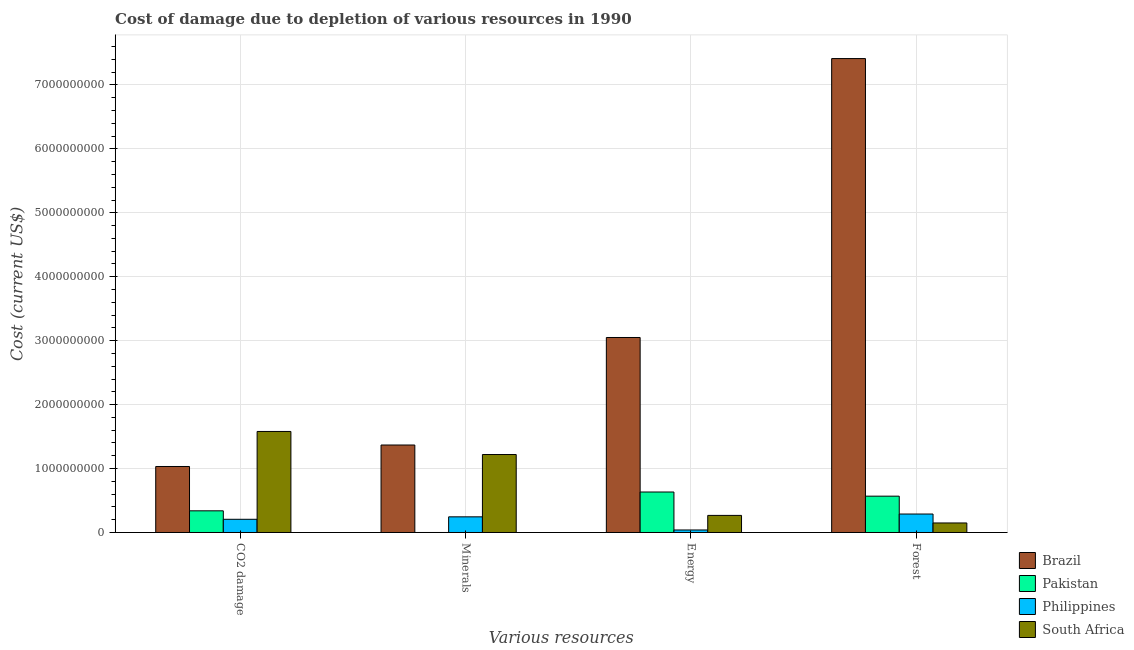How many different coloured bars are there?
Offer a very short reply. 4. Are the number of bars per tick equal to the number of legend labels?
Provide a short and direct response. Yes. Are the number of bars on each tick of the X-axis equal?
Offer a terse response. Yes. What is the label of the 3rd group of bars from the left?
Your answer should be very brief. Energy. What is the cost of damage due to depletion of forests in Pakistan?
Keep it short and to the point. 5.68e+08. Across all countries, what is the maximum cost of damage due to depletion of energy?
Your answer should be compact. 3.05e+09. Across all countries, what is the minimum cost of damage due to depletion of forests?
Your response must be concise. 1.49e+08. In which country was the cost of damage due to depletion of forests maximum?
Offer a terse response. Brazil. What is the total cost of damage due to depletion of coal in the graph?
Your answer should be compact. 3.16e+09. What is the difference between the cost of damage due to depletion of coal in South Africa and that in Brazil?
Make the answer very short. 5.48e+08. What is the difference between the cost of damage due to depletion of minerals in Brazil and the cost of damage due to depletion of coal in South Africa?
Keep it short and to the point. -2.12e+08. What is the average cost of damage due to depletion of coal per country?
Your answer should be very brief. 7.89e+08. What is the difference between the cost of damage due to depletion of coal and cost of damage due to depletion of energy in Brazil?
Your answer should be very brief. -2.02e+09. What is the ratio of the cost of damage due to depletion of minerals in South Africa to that in Pakistan?
Give a very brief answer. 3.53e+04. Is the cost of damage due to depletion of forests in Pakistan less than that in Philippines?
Give a very brief answer. No. Is the difference between the cost of damage due to depletion of forests in Pakistan and Philippines greater than the difference between the cost of damage due to depletion of coal in Pakistan and Philippines?
Provide a succinct answer. Yes. What is the difference between the highest and the second highest cost of damage due to depletion of minerals?
Provide a short and direct response. 1.49e+08. What is the difference between the highest and the lowest cost of damage due to depletion of energy?
Provide a short and direct response. 3.01e+09. In how many countries, is the cost of damage due to depletion of minerals greater than the average cost of damage due to depletion of minerals taken over all countries?
Offer a terse response. 2. Is the sum of the cost of damage due to depletion of forests in Pakistan and South Africa greater than the maximum cost of damage due to depletion of energy across all countries?
Your response must be concise. No. What does the 2nd bar from the left in Minerals represents?
Your answer should be very brief. Pakistan. What does the 4th bar from the right in Minerals represents?
Provide a short and direct response. Brazil. How many bars are there?
Your response must be concise. 16. Does the graph contain any zero values?
Make the answer very short. No. Where does the legend appear in the graph?
Keep it short and to the point. Bottom right. What is the title of the graph?
Your answer should be very brief. Cost of damage due to depletion of various resources in 1990 . Does "Burundi" appear as one of the legend labels in the graph?
Provide a short and direct response. No. What is the label or title of the X-axis?
Give a very brief answer. Various resources. What is the label or title of the Y-axis?
Offer a very short reply. Cost (current US$). What is the Cost (current US$) of Brazil in CO2 damage?
Offer a very short reply. 1.03e+09. What is the Cost (current US$) of Pakistan in CO2 damage?
Your response must be concise. 3.39e+08. What is the Cost (current US$) in Philippines in CO2 damage?
Your answer should be very brief. 2.06e+08. What is the Cost (current US$) of South Africa in CO2 damage?
Make the answer very short. 1.58e+09. What is the Cost (current US$) in Brazil in Minerals?
Make the answer very short. 1.37e+09. What is the Cost (current US$) in Pakistan in Minerals?
Provide a succinct answer. 3.45e+04. What is the Cost (current US$) of Philippines in Minerals?
Ensure brevity in your answer.  2.45e+08. What is the Cost (current US$) of South Africa in Minerals?
Provide a succinct answer. 1.22e+09. What is the Cost (current US$) of Brazil in Energy?
Offer a terse response. 3.05e+09. What is the Cost (current US$) in Pakistan in Energy?
Provide a succinct answer. 6.33e+08. What is the Cost (current US$) in Philippines in Energy?
Your response must be concise. 3.93e+07. What is the Cost (current US$) of South Africa in Energy?
Provide a succinct answer. 2.67e+08. What is the Cost (current US$) in Brazil in Forest?
Provide a short and direct response. 7.41e+09. What is the Cost (current US$) in Pakistan in Forest?
Ensure brevity in your answer.  5.68e+08. What is the Cost (current US$) of Philippines in Forest?
Your answer should be compact. 2.89e+08. What is the Cost (current US$) in South Africa in Forest?
Your answer should be very brief. 1.49e+08. Across all Various resources, what is the maximum Cost (current US$) in Brazil?
Offer a very short reply. 7.41e+09. Across all Various resources, what is the maximum Cost (current US$) of Pakistan?
Your response must be concise. 6.33e+08. Across all Various resources, what is the maximum Cost (current US$) in Philippines?
Provide a short and direct response. 2.89e+08. Across all Various resources, what is the maximum Cost (current US$) of South Africa?
Provide a short and direct response. 1.58e+09. Across all Various resources, what is the minimum Cost (current US$) of Brazil?
Provide a short and direct response. 1.03e+09. Across all Various resources, what is the minimum Cost (current US$) of Pakistan?
Keep it short and to the point. 3.45e+04. Across all Various resources, what is the minimum Cost (current US$) in Philippines?
Offer a terse response. 3.93e+07. Across all Various resources, what is the minimum Cost (current US$) of South Africa?
Keep it short and to the point. 1.49e+08. What is the total Cost (current US$) in Brazil in the graph?
Keep it short and to the point. 1.29e+1. What is the total Cost (current US$) in Pakistan in the graph?
Ensure brevity in your answer.  1.54e+09. What is the total Cost (current US$) in Philippines in the graph?
Offer a terse response. 7.79e+08. What is the total Cost (current US$) in South Africa in the graph?
Offer a very short reply. 3.22e+09. What is the difference between the Cost (current US$) in Brazil in CO2 damage and that in Minerals?
Ensure brevity in your answer.  -3.36e+08. What is the difference between the Cost (current US$) of Pakistan in CO2 damage and that in Minerals?
Provide a short and direct response. 3.39e+08. What is the difference between the Cost (current US$) in Philippines in CO2 damage and that in Minerals?
Your response must be concise. -3.85e+07. What is the difference between the Cost (current US$) of South Africa in CO2 damage and that in Minerals?
Your response must be concise. 3.61e+08. What is the difference between the Cost (current US$) in Brazil in CO2 damage and that in Energy?
Offer a terse response. -2.02e+09. What is the difference between the Cost (current US$) in Pakistan in CO2 damage and that in Energy?
Your answer should be compact. -2.94e+08. What is the difference between the Cost (current US$) in Philippines in CO2 damage and that in Energy?
Give a very brief answer. 1.67e+08. What is the difference between the Cost (current US$) of South Africa in CO2 damage and that in Energy?
Keep it short and to the point. 1.31e+09. What is the difference between the Cost (current US$) in Brazil in CO2 damage and that in Forest?
Ensure brevity in your answer.  -6.38e+09. What is the difference between the Cost (current US$) of Pakistan in CO2 damage and that in Forest?
Offer a terse response. -2.29e+08. What is the difference between the Cost (current US$) in Philippines in CO2 damage and that in Forest?
Provide a succinct answer. -8.23e+07. What is the difference between the Cost (current US$) of South Africa in CO2 damage and that in Forest?
Your answer should be compact. 1.43e+09. What is the difference between the Cost (current US$) of Brazil in Minerals and that in Energy?
Offer a very short reply. -1.68e+09. What is the difference between the Cost (current US$) in Pakistan in Minerals and that in Energy?
Make the answer very short. -6.33e+08. What is the difference between the Cost (current US$) in Philippines in Minerals and that in Energy?
Offer a terse response. 2.06e+08. What is the difference between the Cost (current US$) in South Africa in Minerals and that in Energy?
Provide a short and direct response. 9.52e+08. What is the difference between the Cost (current US$) in Brazil in Minerals and that in Forest?
Your answer should be compact. -6.04e+09. What is the difference between the Cost (current US$) in Pakistan in Minerals and that in Forest?
Keep it short and to the point. -5.68e+08. What is the difference between the Cost (current US$) of Philippines in Minerals and that in Forest?
Provide a short and direct response. -4.39e+07. What is the difference between the Cost (current US$) of South Africa in Minerals and that in Forest?
Provide a succinct answer. 1.07e+09. What is the difference between the Cost (current US$) of Brazil in Energy and that in Forest?
Give a very brief answer. -4.36e+09. What is the difference between the Cost (current US$) of Pakistan in Energy and that in Forest?
Your answer should be compact. 6.49e+07. What is the difference between the Cost (current US$) of Philippines in Energy and that in Forest?
Provide a succinct answer. -2.49e+08. What is the difference between the Cost (current US$) of South Africa in Energy and that in Forest?
Provide a succinct answer. 1.18e+08. What is the difference between the Cost (current US$) of Brazil in CO2 damage and the Cost (current US$) of Pakistan in Minerals?
Your response must be concise. 1.03e+09. What is the difference between the Cost (current US$) of Brazil in CO2 damage and the Cost (current US$) of Philippines in Minerals?
Ensure brevity in your answer.  7.87e+08. What is the difference between the Cost (current US$) in Brazil in CO2 damage and the Cost (current US$) in South Africa in Minerals?
Provide a short and direct response. -1.87e+08. What is the difference between the Cost (current US$) in Pakistan in CO2 damage and the Cost (current US$) in Philippines in Minerals?
Offer a very short reply. 9.40e+07. What is the difference between the Cost (current US$) of Pakistan in CO2 damage and the Cost (current US$) of South Africa in Minerals?
Keep it short and to the point. -8.81e+08. What is the difference between the Cost (current US$) of Philippines in CO2 damage and the Cost (current US$) of South Africa in Minerals?
Your answer should be compact. -1.01e+09. What is the difference between the Cost (current US$) in Brazil in CO2 damage and the Cost (current US$) in Pakistan in Energy?
Provide a succinct answer. 3.99e+08. What is the difference between the Cost (current US$) of Brazil in CO2 damage and the Cost (current US$) of Philippines in Energy?
Your response must be concise. 9.93e+08. What is the difference between the Cost (current US$) in Brazil in CO2 damage and the Cost (current US$) in South Africa in Energy?
Ensure brevity in your answer.  7.65e+08. What is the difference between the Cost (current US$) of Pakistan in CO2 damage and the Cost (current US$) of Philippines in Energy?
Keep it short and to the point. 2.99e+08. What is the difference between the Cost (current US$) in Pakistan in CO2 damage and the Cost (current US$) in South Africa in Energy?
Ensure brevity in your answer.  7.14e+07. What is the difference between the Cost (current US$) of Philippines in CO2 damage and the Cost (current US$) of South Africa in Energy?
Provide a short and direct response. -6.10e+07. What is the difference between the Cost (current US$) of Brazil in CO2 damage and the Cost (current US$) of Pakistan in Forest?
Offer a very short reply. 4.64e+08. What is the difference between the Cost (current US$) of Brazil in CO2 damage and the Cost (current US$) of Philippines in Forest?
Offer a very short reply. 7.43e+08. What is the difference between the Cost (current US$) of Brazil in CO2 damage and the Cost (current US$) of South Africa in Forest?
Provide a succinct answer. 8.83e+08. What is the difference between the Cost (current US$) of Pakistan in CO2 damage and the Cost (current US$) of Philippines in Forest?
Provide a succinct answer. 5.01e+07. What is the difference between the Cost (current US$) of Pakistan in CO2 damage and the Cost (current US$) of South Africa in Forest?
Your response must be concise. 1.90e+08. What is the difference between the Cost (current US$) of Philippines in CO2 damage and the Cost (current US$) of South Africa in Forest?
Your response must be concise. 5.74e+07. What is the difference between the Cost (current US$) in Brazil in Minerals and the Cost (current US$) in Pakistan in Energy?
Your answer should be very brief. 7.35e+08. What is the difference between the Cost (current US$) in Brazil in Minerals and the Cost (current US$) in Philippines in Energy?
Offer a terse response. 1.33e+09. What is the difference between the Cost (current US$) in Brazil in Minerals and the Cost (current US$) in South Africa in Energy?
Your response must be concise. 1.10e+09. What is the difference between the Cost (current US$) in Pakistan in Minerals and the Cost (current US$) in Philippines in Energy?
Keep it short and to the point. -3.93e+07. What is the difference between the Cost (current US$) in Pakistan in Minerals and the Cost (current US$) in South Africa in Energy?
Ensure brevity in your answer.  -2.67e+08. What is the difference between the Cost (current US$) of Philippines in Minerals and the Cost (current US$) of South Africa in Energy?
Make the answer very short. -2.25e+07. What is the difference between the Cost (current US$) in Brazil in Minerals and the Cost (current US$) in Pakistan in Forest?
Your answer should be very brief. 8.00e+08. What is the difference between the Cost (current US$) in Brazil in Minerals and the Cost (current US$) in Philippines in Forest?
Offer a very short reply. 1.08e+09. What is the difference between the Cost (current US$) of Brazil in Minerals and the Cost (current US$) of South Africa in Forest?
Ensure brevity in your answer.  1.22e+09. What is the difference between the Cost (current US$) in Pakistan in Minerals and the Cost (current US$) in Philippines in Forest?
Keep it short and to the point. -2.89e+08. What is the difference between the Cost (current US$) in Pakistan in Minerals and the Cost (current US$) in South Africa in Forest?
Your answer should be very brief. -1.49e+08. What is the difference between the Cost (current US$) in Philippines in Minerals and the Cost (current US$) in South Africa in Forest?
Provide a succinct answer. 9.58e+07. What is the difference between the Cost (current US$) of Brazil in Energy and the Cost (current US$) of Pakistan in Forest?
Keep it short and to the point. 2.48e+09. What is the difference between the Cost (current US$) of Brazil in Energy and the Cost (current US$) of Philippines in Forest?
Provide a short and direct response. 2.76e+09. What is the difference between the Cost (current US$) of Brazil in Energy and the Cost (current US$) of South Africa in Forest?
Offer a terse response. 2.90e+09. What is the difference between the Cost (current US$) of Pakistan in Energy and the Cost (current US$) of Philippines in Forest?
Provide a short and direct response. 3.44e+08. What is the difference between the Cost (current US$) in Pakistan in Energy and the Cost (current US$) in South Africa in Forest?
Give a very brief answer. 4.84e+08. What is the difference between the Cost (current US$) in Philippines in Energy and the Cost (current US$) in South Africa in Forest?
Offer a terse response. -1.10e+08. What is the average Cost (current US$) in Brazil per Various resources?
Offer a very short reply. 3.22e+09. What is the average Cost (current US$) of Pakistan per Various resources?
Provide a succinct answer. 3.85e+08. What is the average Cost (current US$) in Philippines per Various resources?
Your response must be concise. 1.95e+08. What is the average Cost (current US$) in South Africa per Various resources?
Ensure brevity in your answer.  8.04e+08. What is the difference between the Cost (current US$) of Brazil and Cost (current US$) of Pakistan in CO2 damage?
Provide a short and direct response. 6.93e+08. What is the difference between the Cost (current US$) in Brazil and Cost (current US$) in Philippines in CO2 damage?
Your answer should be compact. 8.26e+08. What is the difference between the Cost (current US$) of Brazil and Cost (current US$) of South Africa in CO2 damage?
Your response must be concise. -5.48e+08. What is the difference between the Cost (current US$) of Pakistan and Cost (current US$) of Philippines in CO2 damage?
Make the answer very short. 1.32e+08. What is the difference between the Cost (current US$) in Pakistan and Cost (current US$) in South Africa in CO2 damage?
Make the answer very short. -1.24e+09. What is the difference between the Cost (current US$) in Philippines and Cost (current US$) in South Africa in CO2 damage?
Offer a very short reply. -1.37e+09. What is the difference between the Cost (current US$) of Brazil and Cost (current US$) of Pakistan in Minerals?
Keep it short and to the point. 1.37e+09. What is the difference between the Cost (current US$) of Brazil and Cost (current US$) of Philippines in Minerals?
Your answer should be very brief. 1.12e+09. What is the difference between the Cost (current US$) of Brazil and Cost (current US$) of South Africa in Minerals?
Ensure brevity in your answer.  1.49e+08. What is the difference between the Cost (current US$) of Pakistan and Cost (current US$) of Philippines in Minerals?
Your response must be concise. -2.45e+08. What is the difference between the Cost (current US$) in Pakistan and Cost (current US$) in South Africa in Minerals?
Keep it short and to the point. -1.22e+09. What is the difference between the Cost (current US$) in Philippines and Cost (current US$) in South Africa in Minerals?
Ensure brevity in your answer.  -9.75e+08. What is the difference between the Cost (current US$) of Brazil and Cost (current US$) of Pakistan in Energy?
Your answer should be very brief. 2.42e+09. What is the difference between the Cost (current US$) of Brazil and Cost (current US$) of Philippines in Energy?
Keep it short and to the point. 3.01e+09. What is the difference between the Cost (current US$) of Brazil and Cost (current US$) of South Africa in Energy?
Keep it short and to the point. 2.78e+09. What is the difference between the Cost (current US$) of Pakistan and Cost (current US$) of Philippines in Energy?
Make the answer very short. 5.94e+08. What is the difference between the Cost (current US$) in Pakistan and Cost (current US$) in South Africa in Energy?
Ensure brevity in your answer.  3.66e+08. What is the difference between the Cost (current US$) of Philippines and Cost (current US$) of South Africa in Energy?
Your response must be concise. -2.28e+08. What is the difference between the Cost (current US$) in Brazil and Cost (current US$) in Pakistan in Forest?
Offer a terse response. 6.84e+09. What is the difference between the Cost (current US$) in Brazil and Cost (current US$) in Philippines in Forest?
Provide a succinct answer. 7.12e+09. What is the difference between the Cost (current US$) in Brazil and Cost (current US$) in South Africa in Forest?
Provide a succinct answer. 7.26e+09. What is the difference between the Cost (current US$) of Pakistan and Cost (current US$) of Philippines in Forest?
Keep it short and to the point. 2.79e+08. What is the difference between the Cost (current US$) of Pakistan and Cost (current US$) of South Africa in Forest?
Give a very brief answer. 4.19e+08. What is the difference between the Cost (current US$) of Philippines and Cost (current US$) of South Africa in Forest?
Your answer should be compact. 1.40e+08. What is the ratio of the Cost (current US$) of Brazil in CO2 damage to that in Minerals?
Keep it short and to the point. 0.75. What is the ratio of the Cost (current US$) in Pakistan in CO2 damage to that in Minerals?
Your answer should be compact. 9818.87. What is the ratio of the Cost (current US$) in Philippines in CO2 damage to that in Minerals?
Give a very brief answer. 0.84. What is the ratio of the Cost (current US$) in South Africa in CO2 damage to that in Minerals?
Your response must be concise. 1.3. What is the ratio of the Cost (current US$) of Brazil in CO2 damage to that in Energy?
Ensure brevity in your answer.  0.34. What is the ratio of the Cost (current US$) of Pakistan in CO2 damage to that in Energy?
Your response must be concise. 0.54. What is the ratio of the Cost (current US$) in Philippines in CO2 damage to that in Energy?
Give a very brief answer. 5.25. What is the ratio of the Cost (current US$) in South Africa in CO2 damage to that in Energy?
Make the answer very short. 5.91. What is the ratio of the Cost (current US$) in Brazil in CO2 damage to that in Forest?
Give a very brief answer. 0.14. What is the ratio of the Cost (current US$) of Pakistan in CO2 damage to that in Forest?
Give a very brief answer. 0.6. What is the ratio of the Cost (current US$) in Philippines in CO2 damage to that in Forest?
Make the answer very short. 0.71. What is the ratio of the Cost (current US$) in South Africa in CO2 damage to that in Forest?
Provide a short and direct response. 10.61. What is the ratio of the Cost (current US$) in Brazil in Minerals to that in Energy?
Make the answer very short. 0.45. What is the ratio of the Cost (current US$) of Pakistan in Minerals to that in Energy?
Your answer should be compact. 0. What is the ratio of the Cost (current US$) in Philippines in Minerals to that in Energy?
Keep it short and to the point. 6.23. What is the ratio of the Cost (current US$) of South Africa in Minerals to that in Energy?
Give a very brief answer. 4.56. What is the ratio of the Cost (current US$) of Brazil in Minerals to that in Forest?
Offer a very short reply. 0.18. What is the ratio of the Cost (current US$) in Pakistan in Minerals to that in Forest?
Ensure brevity in your answer.  0. What is the ratio of the Cost (current US$) in Philippines in Minerals to that in Forest?
Ensure brevity in your answer.  0.85. What is the ratio of the Cost (current US$) of South Africa in Minerals to that in Forest?
Offer a terse response. 8.18. What is the ratio of the Cost (current US$) in Brazil in Energy to that in Forest?
Offer a terse response. 0.41. What is the ratio of the Cost (current US$) of Pakistan in Energy to that in Forest?
Keep it short and to the point. 1.11. What is the ratio of the Cost (current US$) of Philippines in Energy to that in Forest?
Make the answer very short. 0.14. What is the ratio of the Cost (current US$) of South Africa in Energy to that in Forest?
Your response must be concise. 1.79. What is the difference between the highest and the second highest Cost (current US$) of Brazil?
Keep it short and to the point. 4.36e+09. What is the difference between the highest and the second highest Cost (current US$) in Pakistan?
Your answer should be compact. 6.49e+07. What is the difference between the highest and the second highest Cost (current US$) in Philippines?
Ensure brevity in your answer.  4.39e+07. What is the difference between the highest and the second highest Cost (current US$) of South Africa?
Offer a terse response. 3.61e+08. What is the difference between the highest and the lowest Cost (current US$) of Brazil?
Your response must be concise. 6.38e+09. What is the difference between the highest and the lowest Cost (current US$) of Pakistan?
Make the answer very short. 6.33e+08. What is the difference between the highest and the lowest Cost (current US$) of Philippines?
Keep it short and to the point. 2.49e+08. What is the difference between the highest and the lowest Cost (current US$) of South Africa?
Provide a short and direct response. 1.43e+09. 